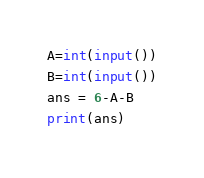<code> <loc_0><loc_0><loc_500><loc_500><_Python_>A=int(input())
B=int(input())
ans = 6-A-B
print(ans)</code> 